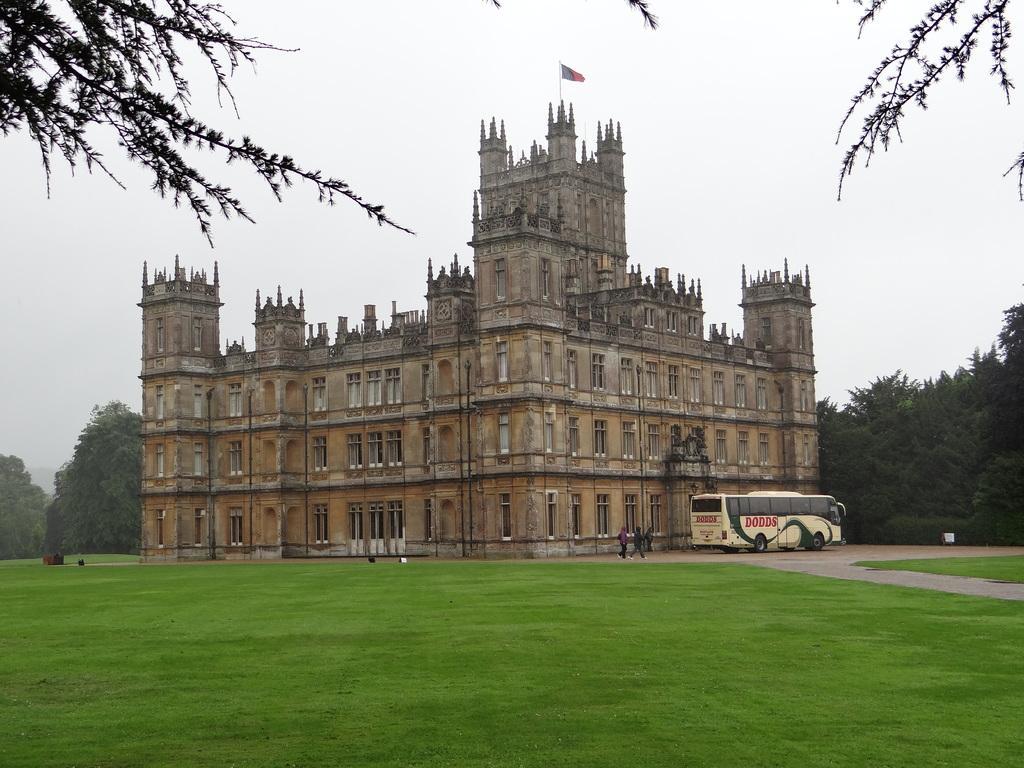Could you give a brief overview of what you see in this image? In this picture I can see there is a fort, it has windows and there are few people walking, there is a bus at right side, there is some grass on the floor and there are trees at left and right side of the image. The sky is clear. 